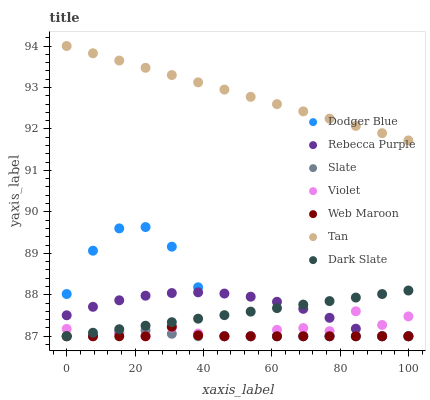Does Web Maroon have the minimum area under the curve?
Answer yes or no. Yes. Does Tan have the maximum area under the curve?
Answer yes or no. Yes. Does Dark Slate have the minimum area under the curve?
Answer yes or no. No. Does Dark Slate have the maximum area under the curve?
Answer yes or no. No. Is Dark Slate the smoothest?
Answer yes or no. Yes. Is Violet the roughest?
Answer yes or no. Yes. Is Web Maroon the smoothest?
Answer yes or no. No. Is Web Maroon the roughest?
Answer yes or no. No. Does Slate have the lowest value?
Answer yes or no. Yes. Does Tan have the lowest value?
Answer yes or no. No. Does Tan have the highest value?
Answer yes or no. Yes. Does Web Maroon have the highest value?
Answer yes or no. No. Is Dodger Blue less than Tan?
Answer yes or no. Yes. Is Tan greater than Dark Slate?
Answer yes or no. Yes. Does Violet intersect Dark Slate?
Answer yes or no. Yes. Is Violet less than Dark Slate?
Answer yes or no. No. Is Violet greater than Dark Slate?
Answer yes or no. No. Does Dodger Blue intersect Tan?
Answer yes or no. No. 